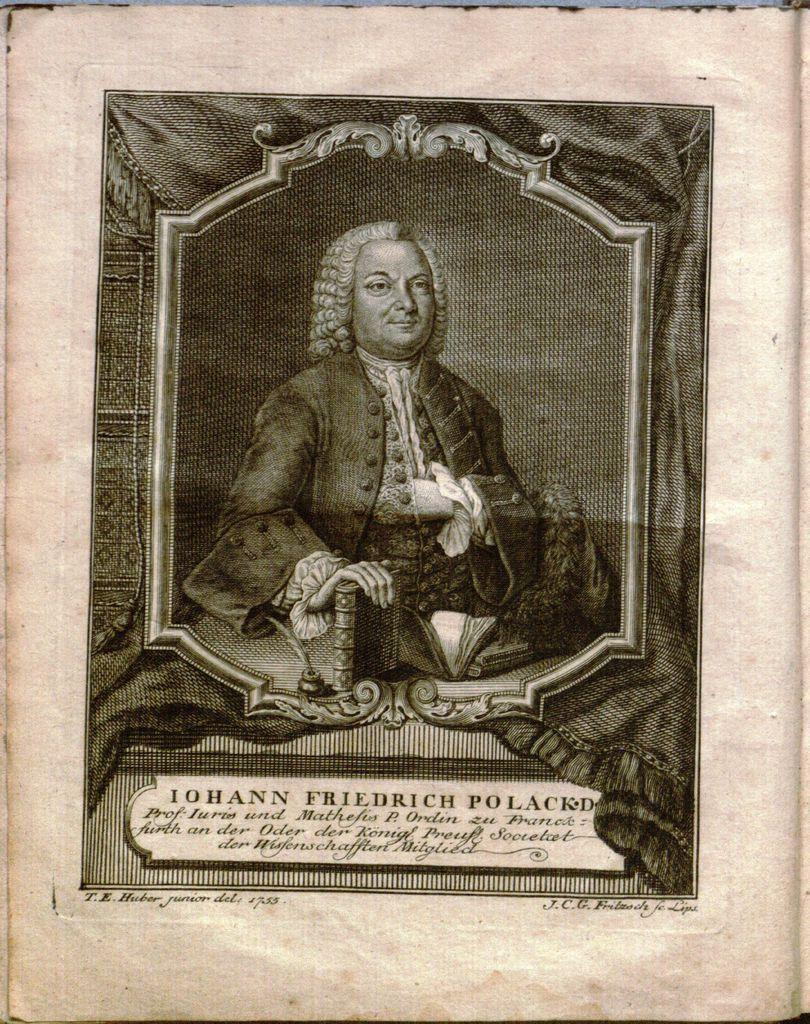What is the main subject of the image? There is a picture of a man in the image. What else can be seen in the image besides the man? There is text on a paper in the image. What type of yarn is being used to create the stem of the playground equipment in the image? There is no playground equipment or yarn present in the image; it features a picture of a man and text on a paper. 